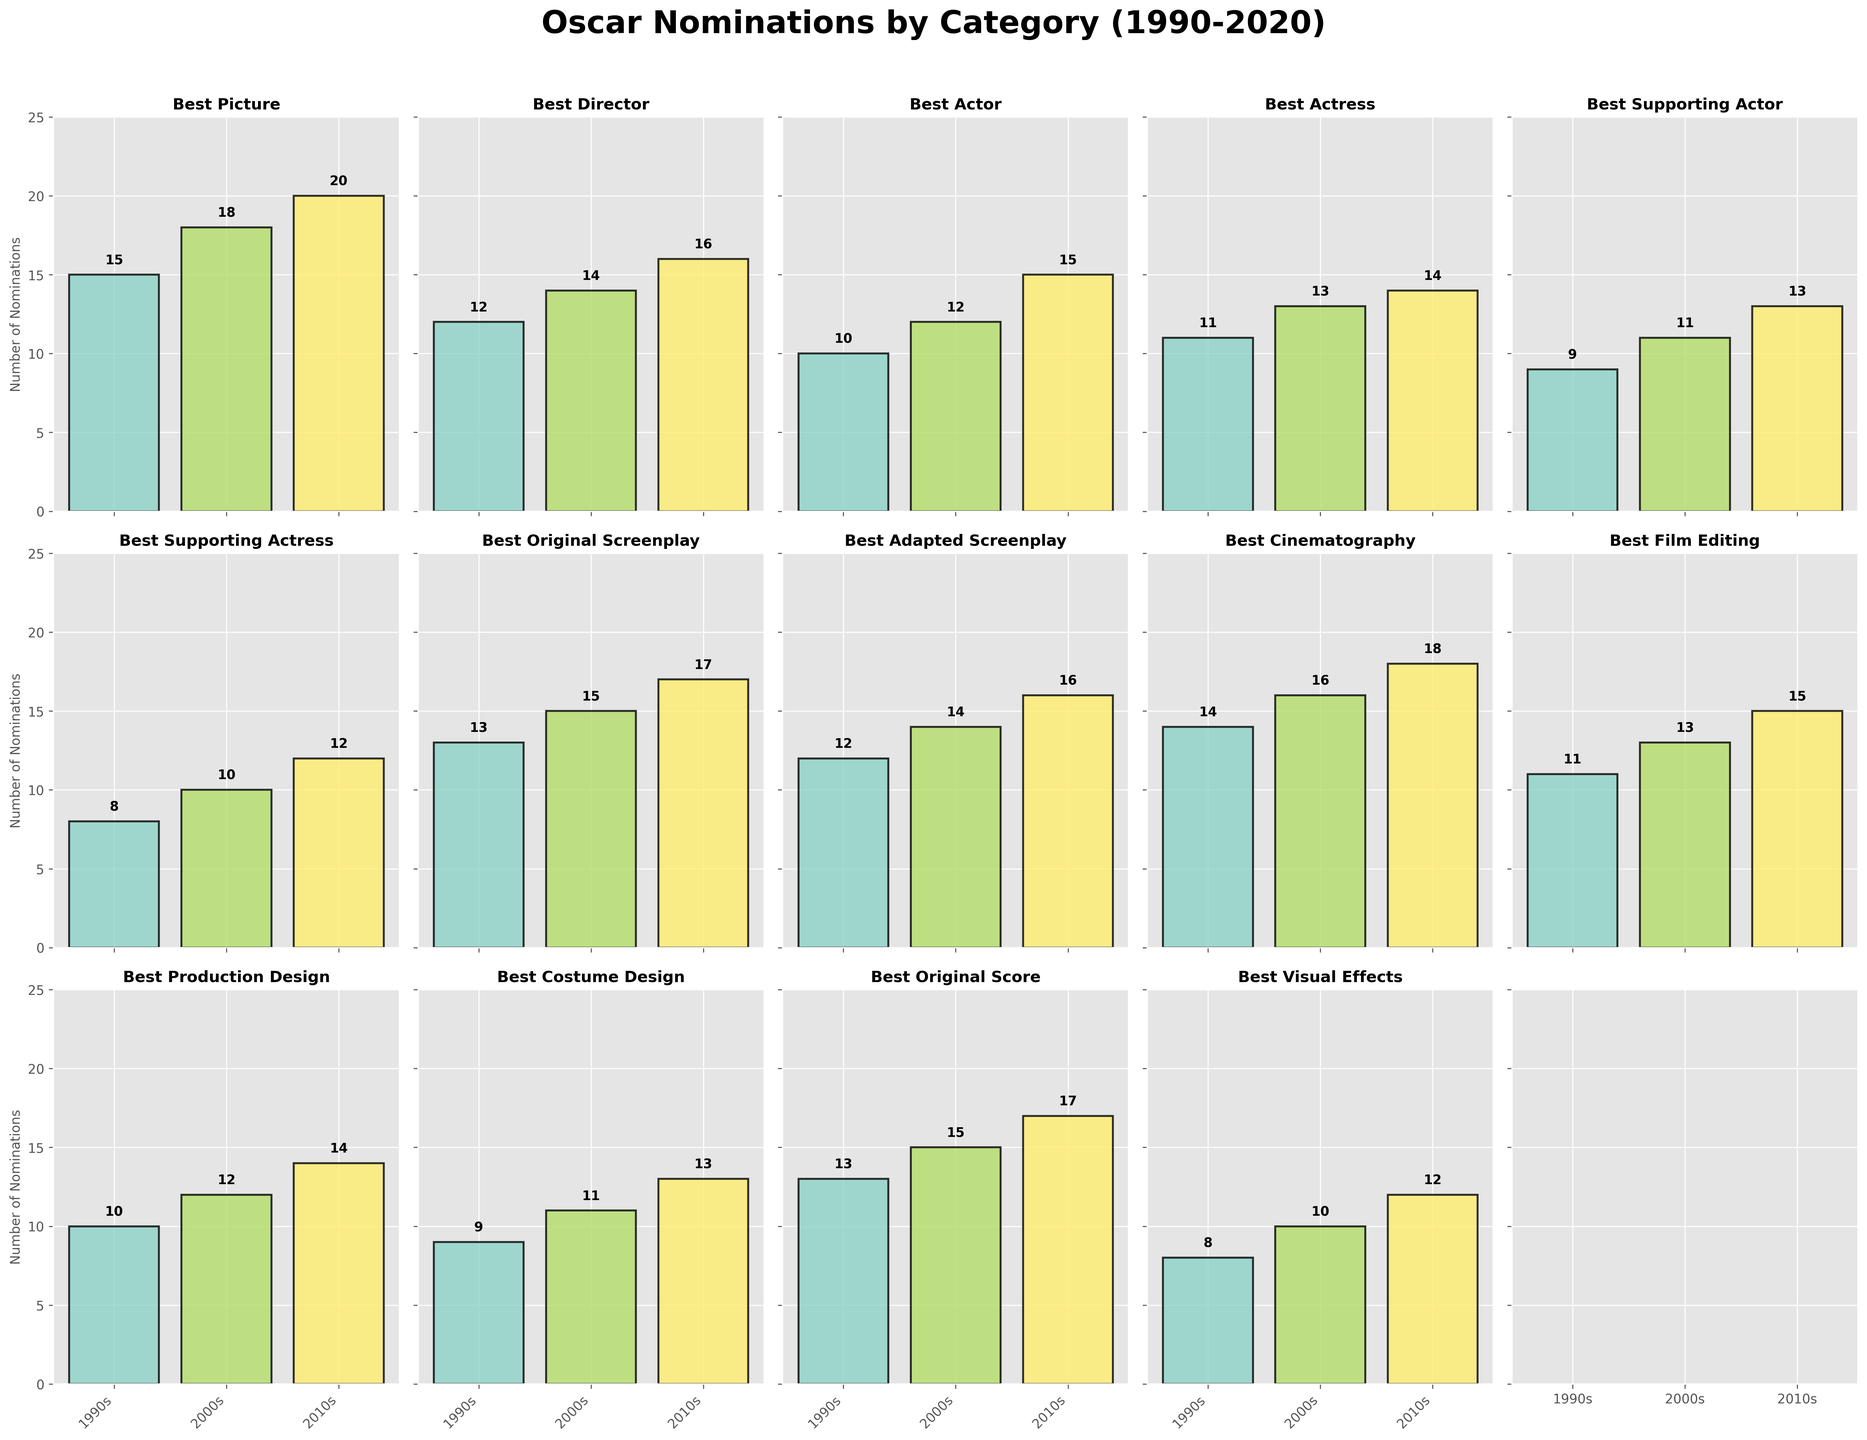How many Oscar nominations did the "Best Picture" category have in the 2010s? Look at the subplot titled "Best Picture" and refer to the bar that represents the 2010s. The label above this bar shows the number of nominations.
Answer: 20 Which category saw an increase from the 1990s to the 2000s and again from the 2000s to the 2010s? Identify the subplots where the bars for each decade (1990s, 2000s, 2010s) show an increasing trend.
Answer: Best Picture, Best Director, Best Actor, Best Actress, Best Supporting Actor, Best Supporting Actress, Best Original Screenplay, Best Adapted Screenplay, Best Cinematography, Best Film Editing, Best Production Design, Best Costume Design, Best Original Score, Best Visual Effects What is the total number of Oscar nominations for the "Best Actor" category across all decades? Add the number of nominations for "Best Actor" from the 1990s, 2000s, and 2010s using the data displayed in the respective subplot. 10 + 12 + 15 = 37
Answer: 37 Which category had more nominations in the 2010s: "Best Original Screenplay" or "Best Adapted Screenplay"? Compare the number of nominations in the 2010s for both "Best Original Screenplay" and "Best Adapted Screenplay". As per the subplots, "Best Original Screenplay" has 17 and "Best Adapted Screenplay" has 16.
Answer: Best Original Screenplay What was the difference in nominations between "Best Cinematography" and "Best Supporting Actress" in the 2000s? Subtract the number of nominations for the "Best Supporting Actress" category in the 2000s from those of "Best Cinematography" in the same decade. 16 - 10 = 6
Answer: 6 Which category had the least nominations in the 1990s? Identify the subplot with the lowest bar for the 1990s. "Best Visual Effects" has the least with 8 nominations.
Answer: Best Visual Effects How many more nominations did "Best Director" receive in the 2010s compared to the 1990s? Subtract the number of nominations in the 1990s from the number in the 2010s for "Best Director". 16 - 12 = 4
Answer: 4 Are there any categories where the number of nominations stayed constant across two consecutive decades? Check each subplot to see if any category has the same number of nominations in two consecutive decades.
Answer: No 